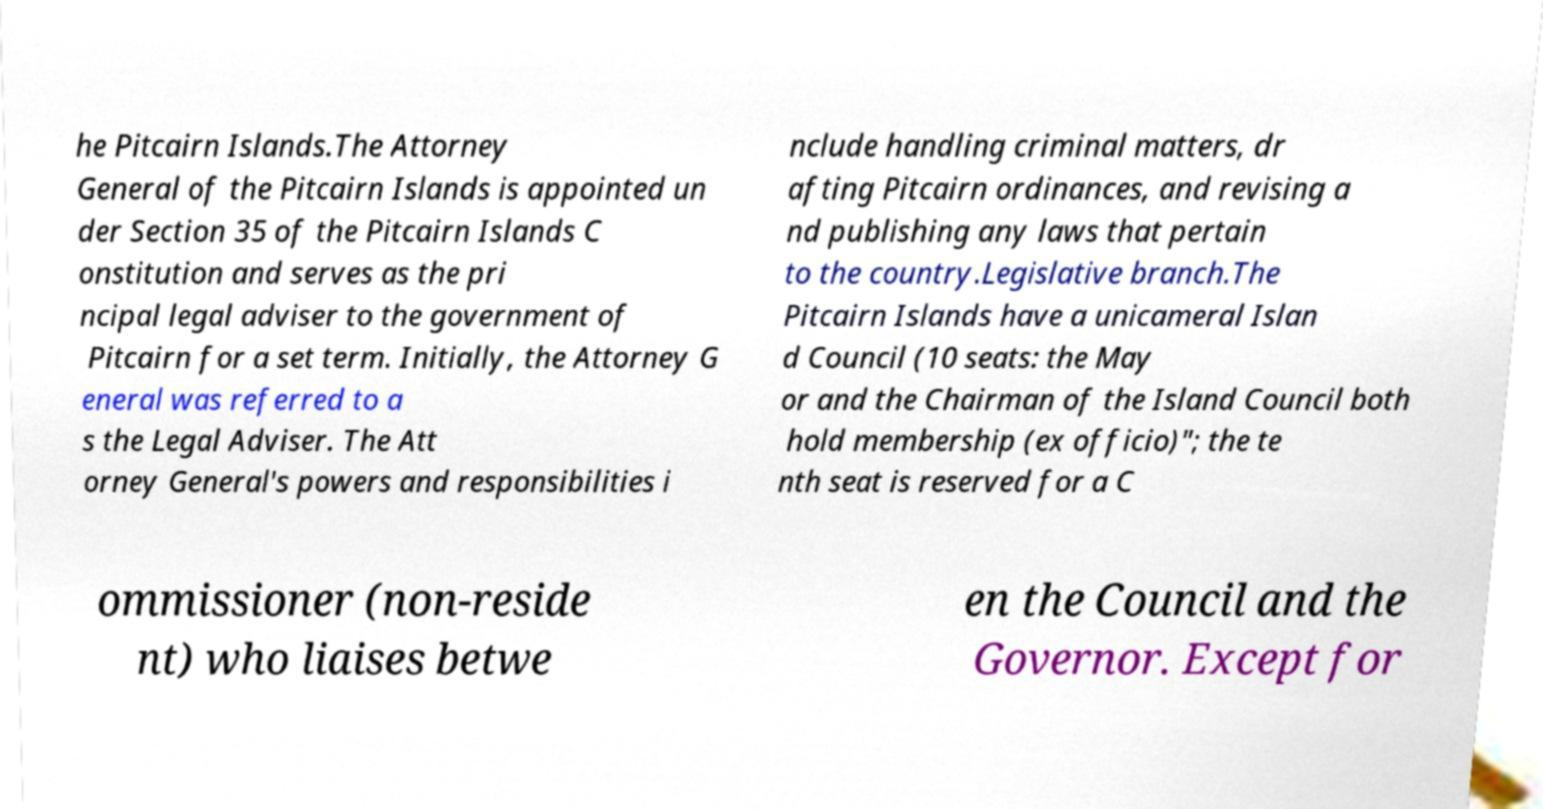I need the written content from this picture converted into text. Can you do that? he Pitcairn Islands.The Attorney General of the Pitcairn Islands is appointed un der Section 35 of the Pitcairn Islands C onstitution and serves as the pri ncipal legal adviser to the government of Pitcairn for a set term. Initially, the Attorney G eneral was referred to a s the Legal Adviser. The Att orney General's powers and responsibilities i nclude handling criminal matters, dr afting Pitcairn ordinances, and revising a nd publishing any laws that pertain to the country.Legislative branch.The Pitcairn Islands have a unicameral Islan d Council (10 seats: the May or and the Chairman of the Island Council both hold membership (ex officio)"; the te nth seat is reserved for a C ommissioner (non-reside nt) who liaises betwe en the Council and the Governor. Except for 